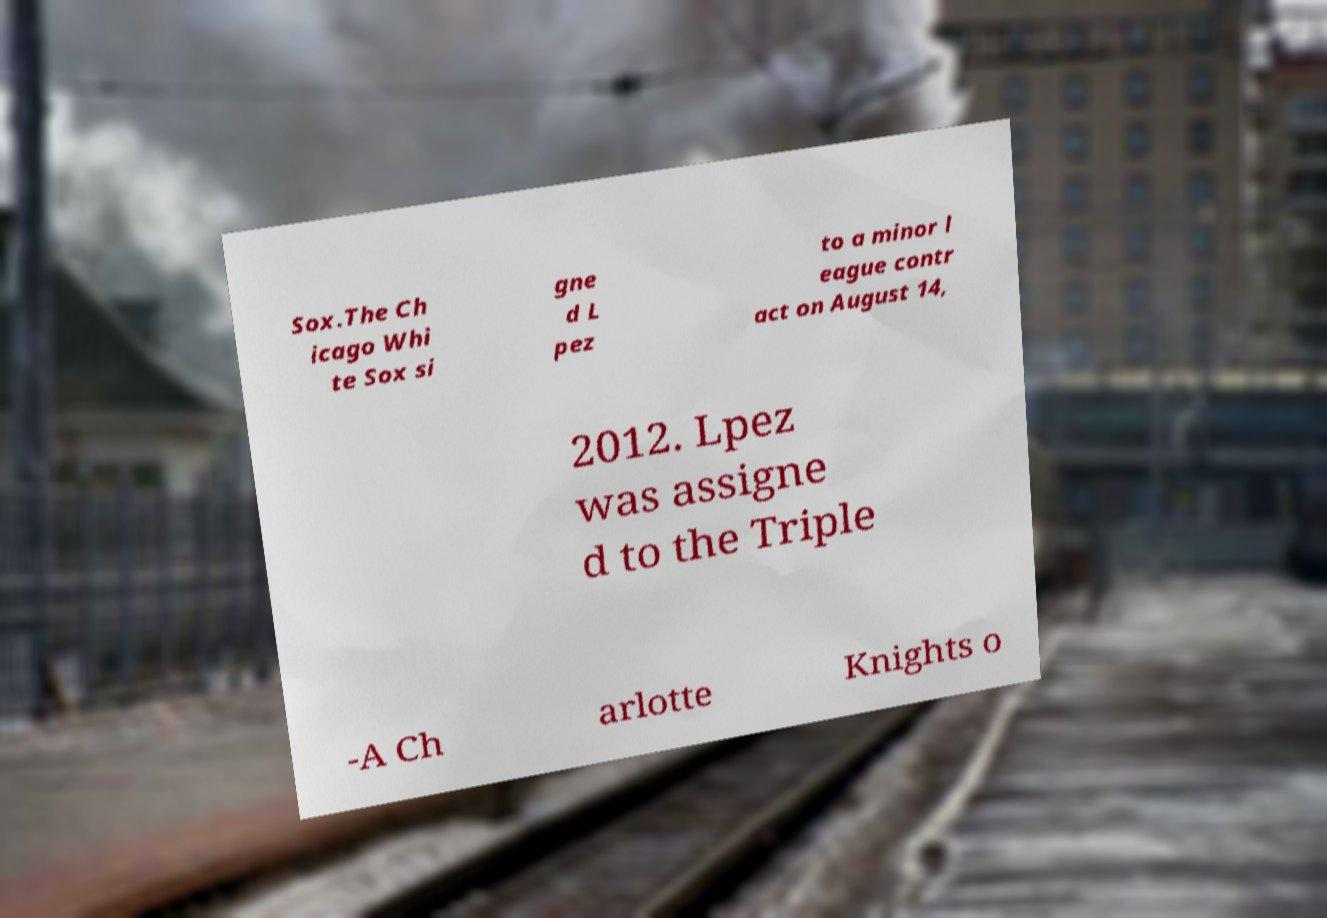Could you extract and type out the text from this image? Sox.The Ch icago Whi te Sox si gne d L pez to a minor l eague contr act on August 14, 2012. Lpez was assigne d to the Triple -A Ch arlotte Knights o 